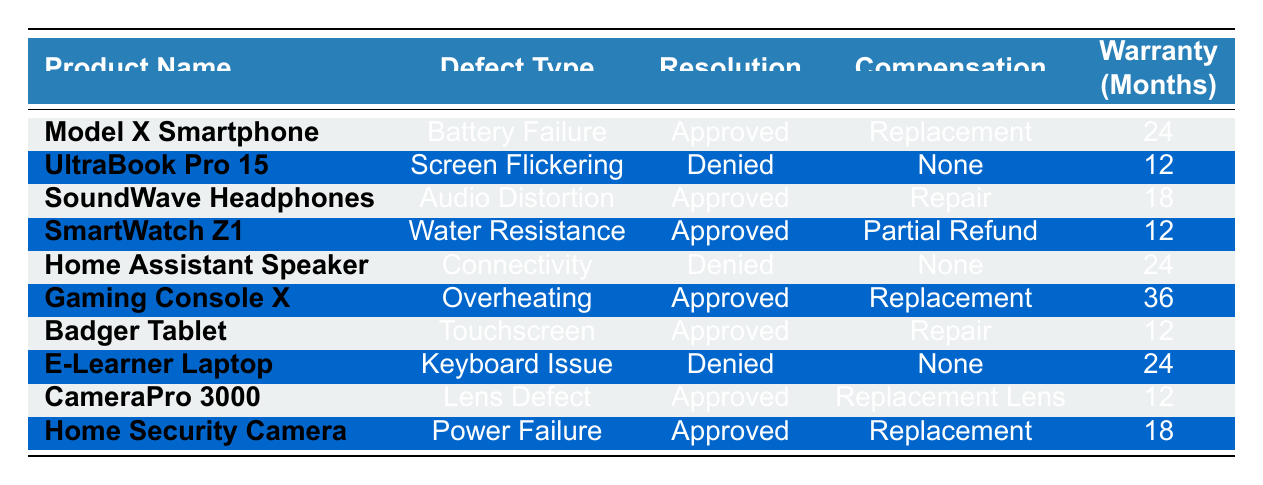What is the compensation for the claim with ID WC001? The claim with ID WC001 pertains to the product "Model X Smartphone" and has a resolution status of "Claim Approved". The compensation awarded for this claim is stated as "Replacement Device" in the table.
Answer: Replacement Device How many months is the warranty period for the "Gaming Console X"? The warranty period for the "Gaming Console X" is listed in the table alongside the respective claims. It is stated as 36 months.
Answer: 36 Which customer received a partial refund as compensation? To find which customer received a partial refund, we can look for the term "Partial Refund" in the compensation column. The entry for "SmartWatch Z1" indicates that Emily Davis received a partial refund.
Answer: Emily Davis Were there any claims denied for products purchased in 2022? By reviewing the table, we can see that two claims were denied: the "UltraBook Pro 15" purchased by Jane Smith in November 2022 and the "Home Assistant Speaker" purchased by David Brown in September 2022. Since both were from 2022, the answer is yes.
Answer: Yes What is the average warranty period for all approved claims? First, we need to identify all claims with the resolution status "Claim Approved". Totalling the warranty months for the approved claims (24 for Model X, 18 for SoundWave Headphones, 12 for SmartWatch Z1, 36 for Gaming Console X, 12 for Badger Tablet, 12 for CameraPro 3000, and 18 for Home Security Camera) gives us a sum of  24 + 18 + 12 + 36 + 12 + 12 + 18 = 132 months. There are 7 approved claims, so the average is 132 / 7 ≈ 18.86 months.
Answer: Approximately 18.86 Which product had a resolution status of "Claim Denied" and was related to a connectivity issue? The "Home Assistant Speaker" is the product in the table that has the resolution status "Claim Denied" and is specifically listed under the defect type "Connectivity Issues".
Answer: Home Assistant Speaker How many products had their claims approved and are related to defects other than "Battery Failure"? The products with approved claims excluding "Battery Failure" are "SoundWave Headphones" (Audio Distortion), "SmartWatch Z1" (Water Resistance Failure), "Gaming Console X" (Overheating), "Badger Tablet" (Touchscreen Malfunction), "CameraPro 3000" (Lens Defect), and "Home Security Camera" (Power Failure). That totals to 6 products.
Answer: 6 Did any of the claims result in compensation other than "Replacement Device"? By examining the table, we find that claims resulting in compensation other than "Replacement Device" include "Repair Service" for SoundWave Headphones, "Partial Refund" for SmartWatch Z1, "Replacement Lens" for CameraPro 3000, and "No Compensation" for both denied claims, resulting in a conclusion that there were indeed claims with other compensations apart from "Replacement Device".
Answer: Yes 